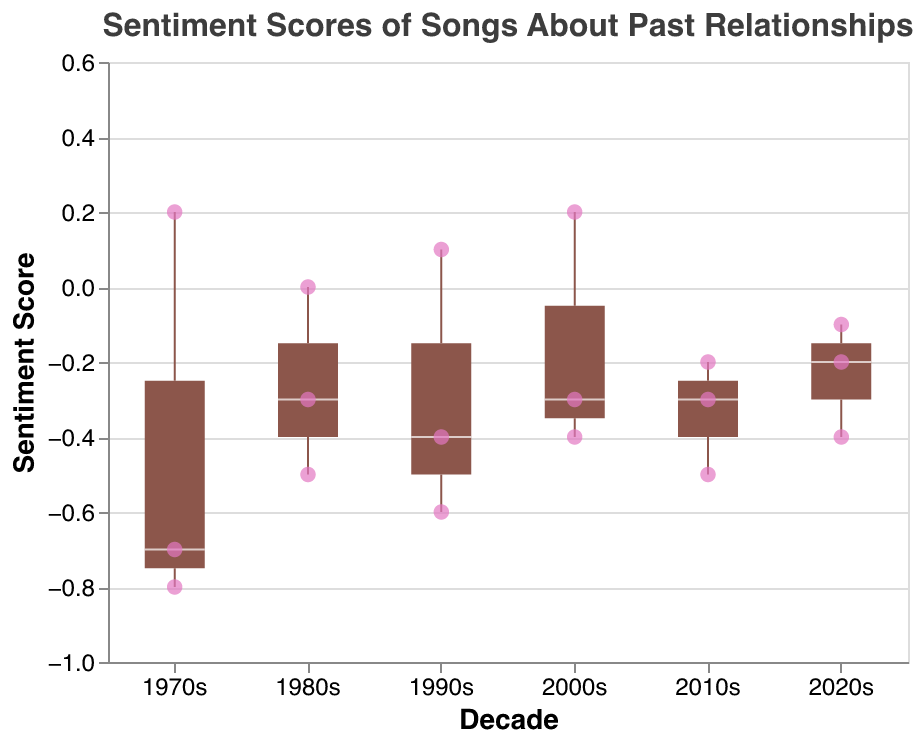What's the median sentiment score for songs in the 2010s? To find the median sentiment score for the 2010s, look at the central tendency marker within the box plot for that decade.
Answer: -0.3 Which decade has the lowest minimum sentiment score? To find the lowest minimum sentiment score, compare the bottom whiskers of each decade's box plot. The decade with the lowest whisker has the lowest minimum sentiment score.
Answer: 1970s How many songs from the 1980s have a sentiment score above 0? Look at the scatter points within the 1980s. Count the number of points with a sentiment score above 0.
Answer: 0 What is the range of sentiment scores for songs from the 2000s? The range is calculated by the difference between the maximum and minimum sentiment scores within the box plot for the 2000s. The maximum is around 0.2 and the minimum around -0.4, so the range is 0.6.
Answer: 0.6 Between Adele's songs in the 2010s and the 2020s, which decade has the higher sentiment score? Refer to the scatter points representing Adele's songs. Compare "Someone Like You" (2010s, -0.5) and "Easy On Me" (2020s, -0.2) to see which has the higher sentiment score.
Answer: 2020s In which decade is the sentiment score variability the greatest? Sentiment score variability is indicated by the length of the box and whiskers. Compare the length of the boxes and whiskers among decades to find the one with the greatest variability.
Answer: 1970s Are there any outliers in the sentiment scores? In a box plot, outliers are usually points that fall outside the whiskers. Check each decade for any points falling outside the whiskers. There are no clear outliers shown.
Answer: No Which decade shows the most balanced sentiment scores around the median? A balanced distribution is indicated by a symmetric box around the median line. Compare the symmetry of the boxes and whiskers around the median across decades.
Answer: 2010s Do songs about past relationships become generally more positive or negative over the decades? To analyze the trend, observe the general shifts in median value of the sentiment scores across the decades. Most medians hover between -0.5 to 0.1 indicating no clear shift over the decades, but higher recent medians indicate a slight positive shift.
Answer: Slightly more positive What is the highest sentiment score and which song does it belong to? Identify the scatter point with the highest position in terms of sentiment score. The tooltip should indicate the corresponding song.
Answer: Tangled Up in Blue 